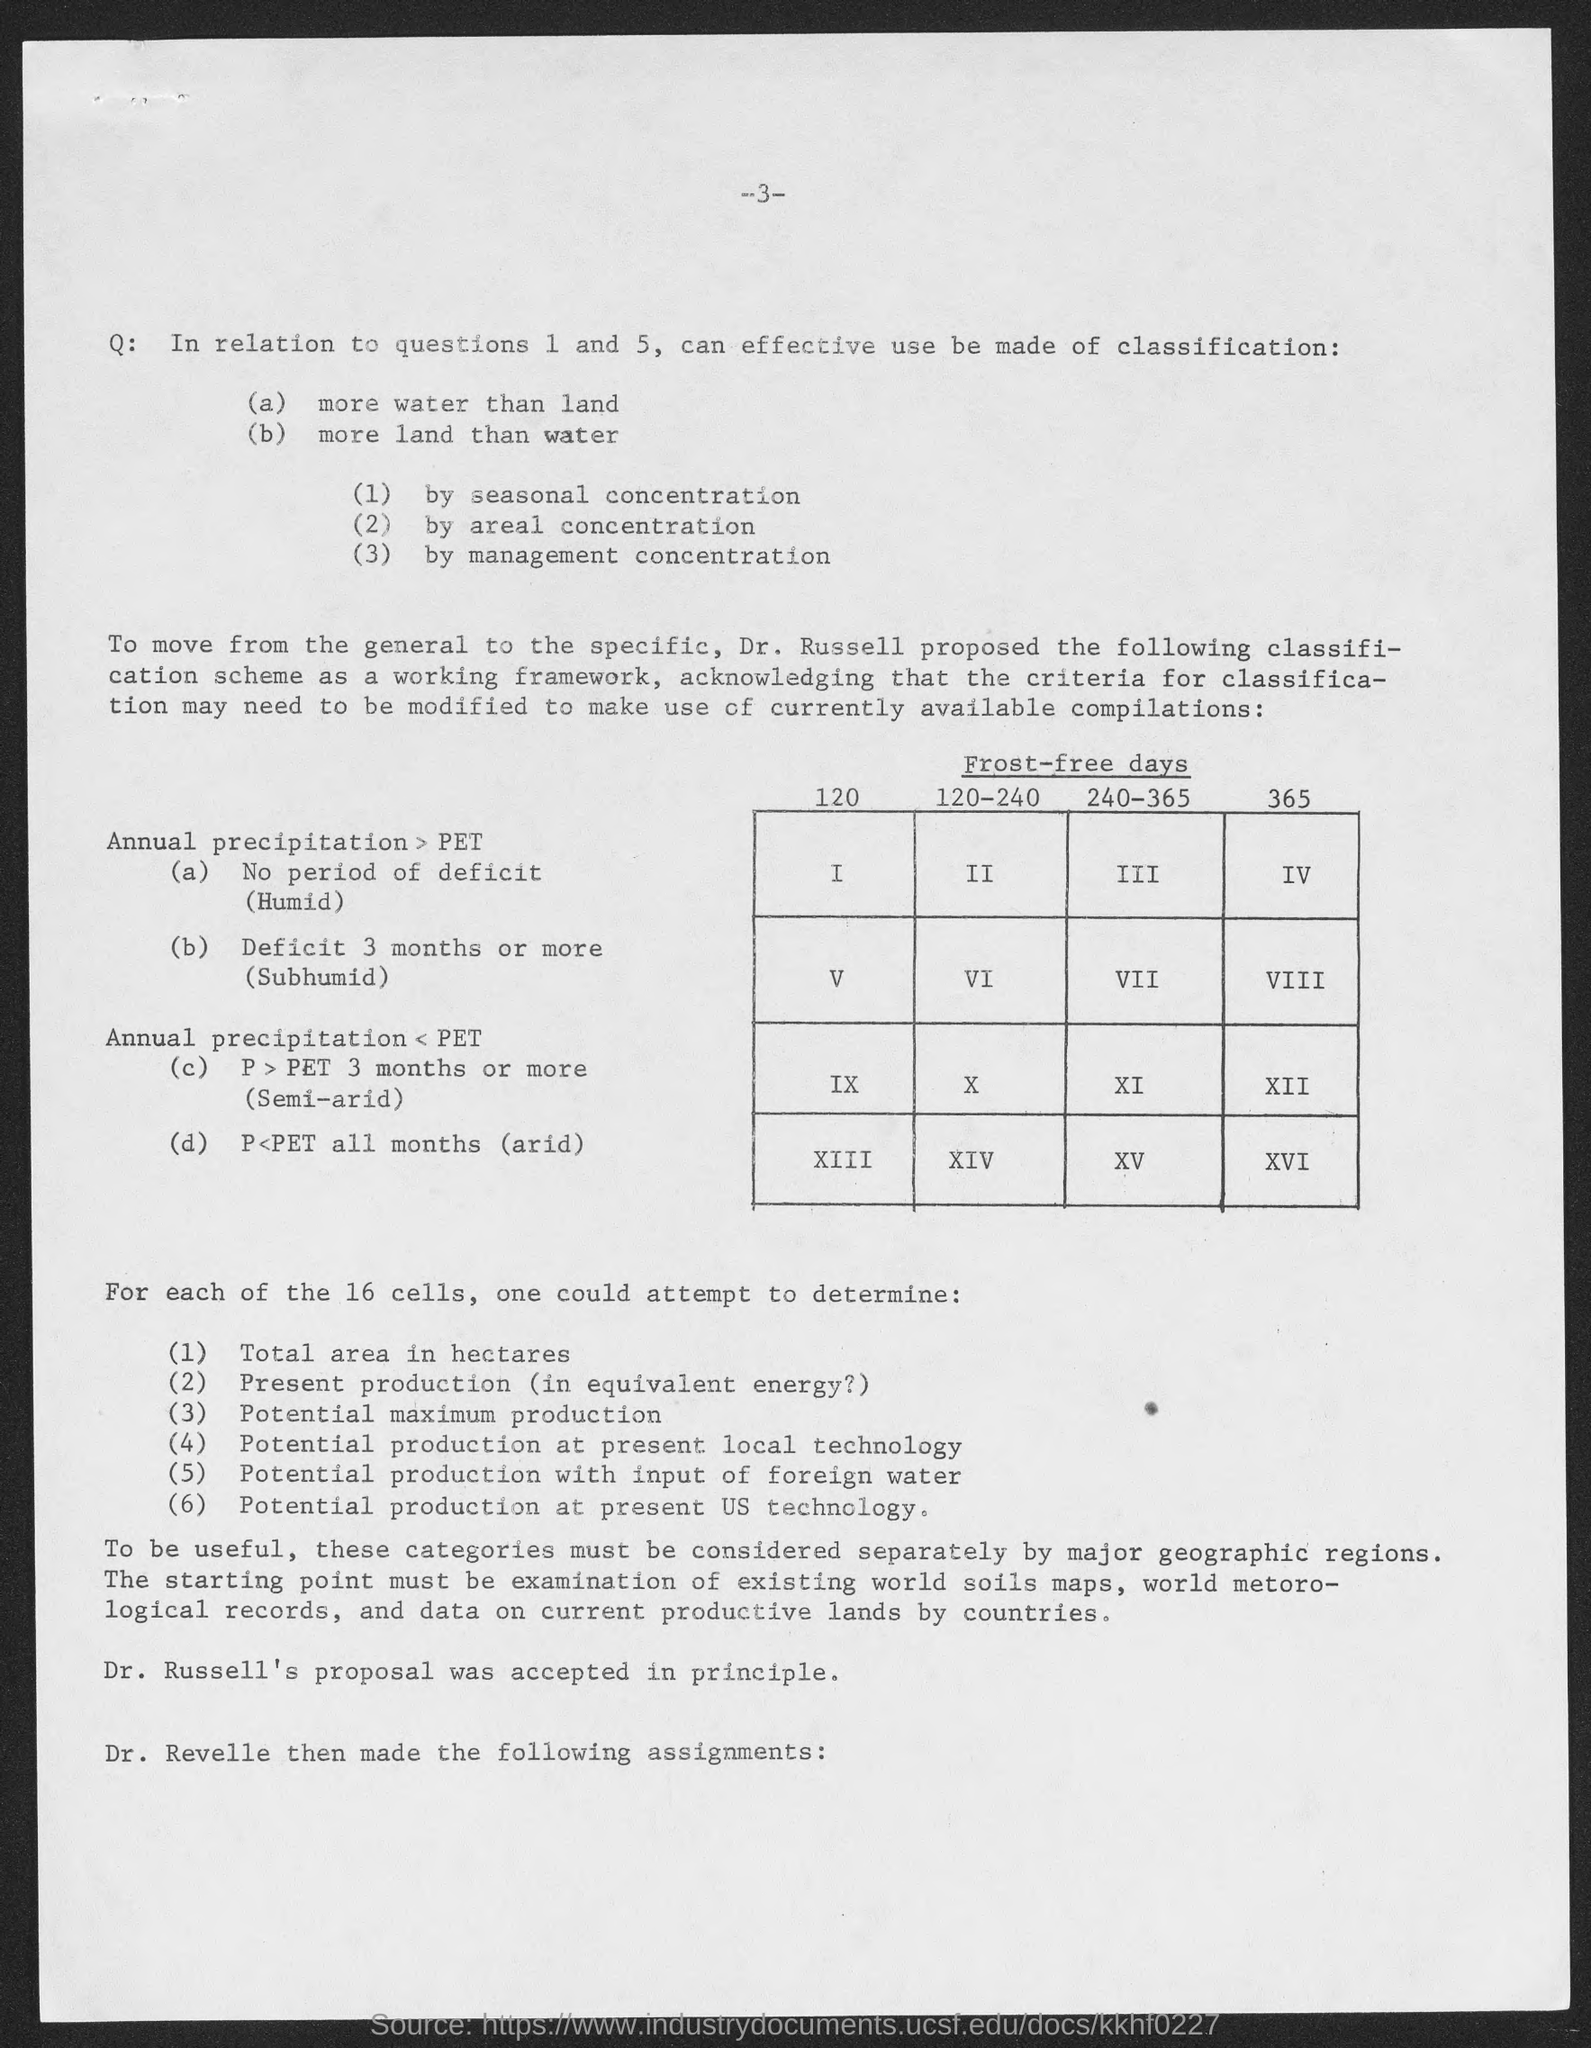Indicate a few pertinent items in this graphic. The title of the table is "Frost-free days in Canada from 1981 to 2010. 